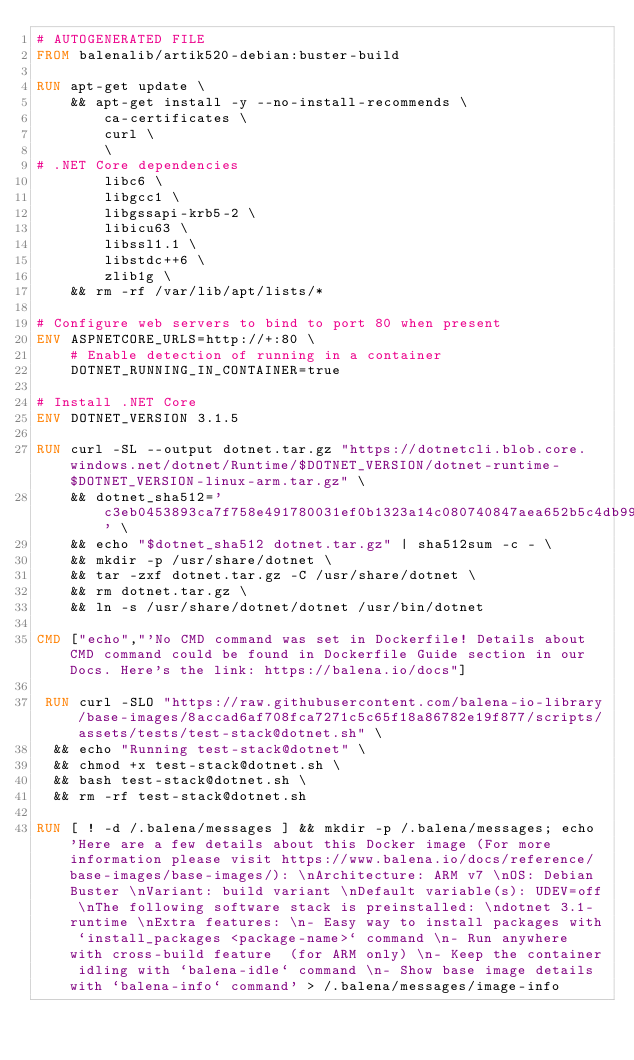Convert code to text. <code><loc_0><loc_0><loc_500><loc_500><_Dockerfile_># AUTOGENERATED FILE
FROM balenalib/artik520-debian:buster-build

RUN apt-get update \
    && apt-get install -y --no-install-recommends \
        ca-certificates \
        curl \
        \
# .NET Core dependencies
        libc6 \
        libgcc1 \
        libgssapi-krb5-2 \
        libicu63 \
        libssl1.1 \
        libstdc++6 \
        zlib1g \
    && rm -rf /var/lib/apt/lists/*

# Configure web servers to bind to port 80 when present
ENV ASPNETCORE_URLS=http://+:80 \
    # Enable detection of running in a container
    DOTNET_RUNNING_IN_CONTAINER=true

# Install .NET Core
ENV DOTNET_VERSION 3.1.5

RUN curl -SL --output dotnet.tar.gz "https://dotnetcli.blob.core.windows.net/dotnet/Runtime/$DOTNET_VERSION/dotnet-runtime-$DOTNET_VERSION-linux-arm.tar.gz" \
    && dotnet_sha512='c3eb0453893ca7f758e491780031ef0b1323a14c080740847aea652b5c4db99d30e8b3b27fcd306c3a098dc838572c41d3ea871156ba62d9302df32e63a28835' \
    && echo "$dotnet_sha512 dotnet.tar.gz" | sha512sum -c - \
    && mkdir -p /usr/share/dotnet \
    && tar -zxf dotnet.tar.gz -C /usr/share/dotnet \
    && rm dotnet.tar.gz \
    && ln -s /usr/share/dotnet/dotnet /usr/bin/dotnet

CMD ["echo","'No CMD command was set in Dockerfile! Details about CMD command could be found in Dockerfile Guide section in our Docs. Here's the link: https://balena.io/docs"]

 RUN curl -SLO "https://raw.githubusercontent.com/balena-io-library/base-images/8accad6af708fca7271c5c65f18a86782e19f877/scripts/assets/tests/test-stack@dotnet.sh" \
  && echo "Running test-stack@dotnet" \
  && chmod +x test-stack@dotnet.sh \
  && bash test-stack@dotnet.sh \
  && rm -rf test-stack@dotnet.sh 

RUN [ ! -d /.balena/messages ] && mkdir -p /.balena/messages; echo 'Here are a few details about this Docker image (For more information please visit https://www.balena.io/docs/reference/base-images/base-images/): \nArchitecture: ARM v7 \nOS: Debian Buster \nVariant: build variant \nDefault variable(s): UDEV=off \nThe following software stack is preinstalled: \ndotnet 3.1-runtime \nExtra features: \n- Easy way to install packages with `install_packages <package-name>` command \n- Run anywhere with cross-build feature  (for ARM only) \n- Keep the container idling with `balena-idle` command \n- Show base image details with `balena-info` command' > /.balena/messages/image-info
</code> 